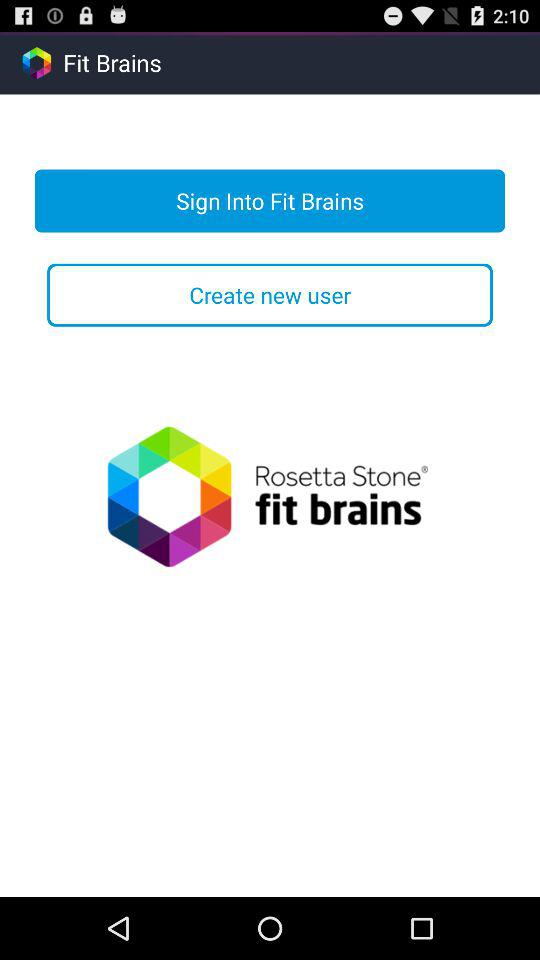What is the name of the application? The name of the application is "Fit Brains". 